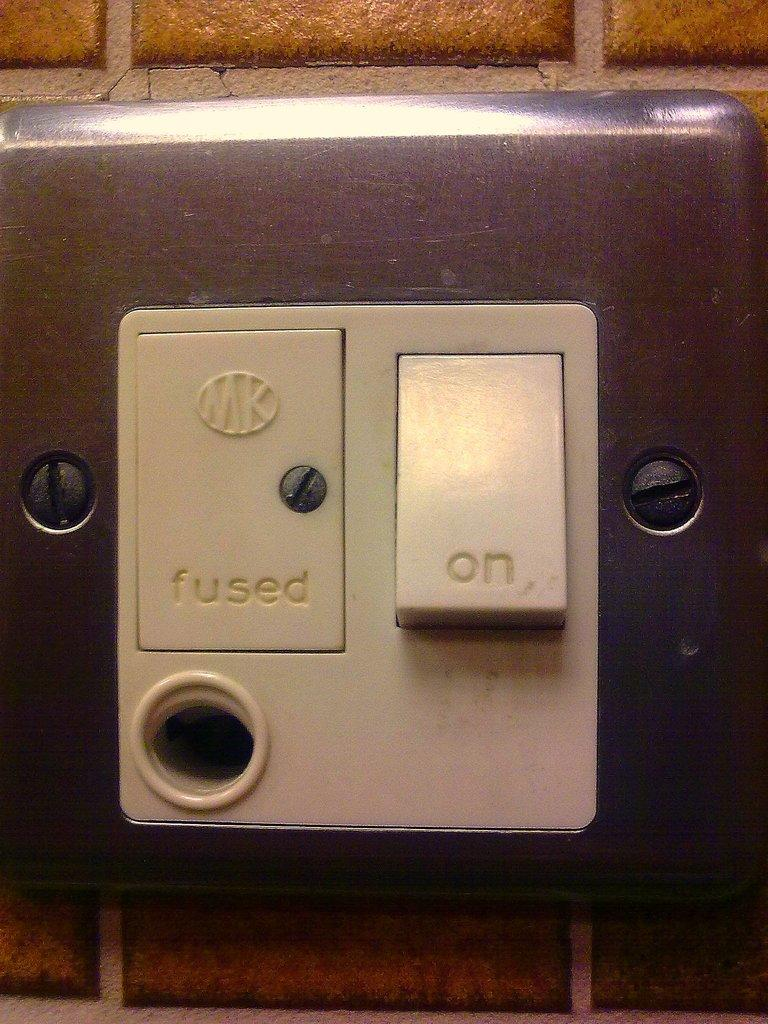Provide a one-sentence caption for the provided image. A switch where the On switch is turned on. 